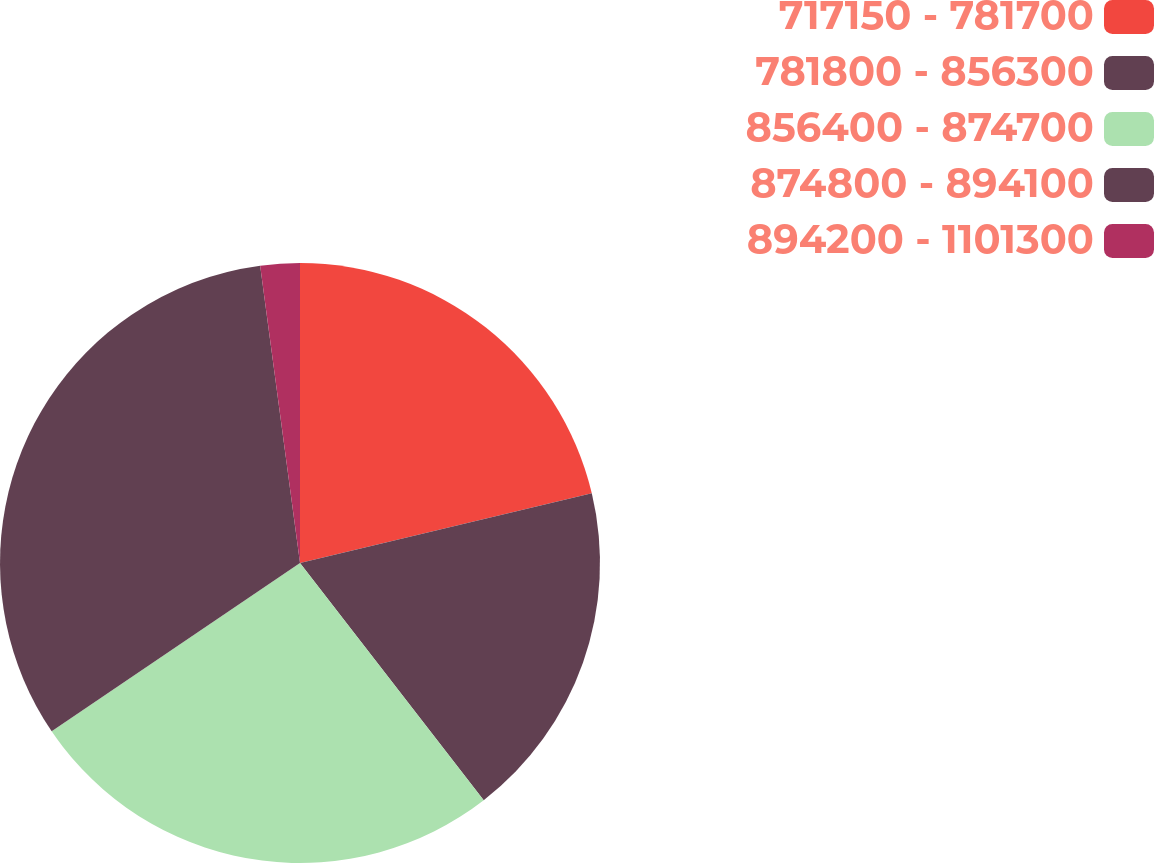Convert chart to OTSL. <chart><loc_0><loc_0><loc_500><loc_500><pie_chart><fcel>717150 - 781700<fcel>781800 - 856300<fcel>856400 - 874700<fcel>874800 - 894100<fcel>894200 - 1101300<nl><fcel>21.27%<fcel>18.24%<fcel>26.01%<fcel>32.36%<fcel>2.12%<nl></chart> 